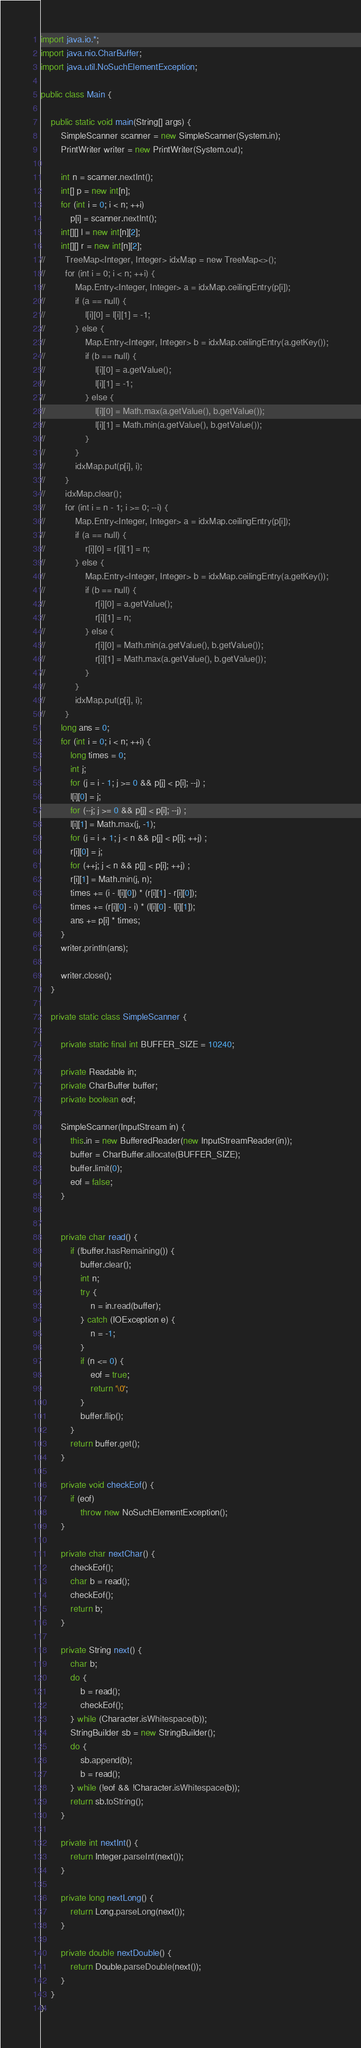<code> <loc_0><loc_0><loc_500><loc_500><_Java_>import java.io.*;
import java.nio.CharBuffer;
import java.util.NoSuchElementException;

public class Main {

    public static void main(String[] args) {
        SimpleScanner scanner = new SimpleScanner(System.in);
        PrintWriter writer = new PrintWriter(System.out);

        int n = scanner.nextInt();
        int[] p = new int[n];
        for (int i = 0; i < n; ++i)
            p[i] = scanner.nextInt();
        int[][] l = new int[n][2];
        int[][] r = new int[n][2];
//        TreeMap<Integer, Integer> idxMap = new TreeMap<>();
//        for (int i = 0; i < n; ++i) {
//            Map.Entry<Integer, Integer> a = idxMap.ceilingEntry(p[i]);
//            if (a == null) {
//                l[i][0] = l[i][1] = -1;
//            } else {
//                Map.Entry<Integer, Integer> b = idxMap.ceilingEntry(a.getKey());
//                if (b == null) {
//                    l[i][0] = a.getValue();
//                    l[i][1] = -1;
//                } else {
//                    l[i][0] = Math.max(a.getValue(), b.getValue());
//                    l[i][1] = Math.min(a.getValue(), b.getValue());
//                }
//            }
//            idxMap.put(p[i], i);
//        }
//        idxMap.clear();
//        for (int i = n - 1; i >= 0; --i) {
//            Map.Entry<Integer, Integer> a = idxMap.ceilingEntry(p[i]);
//            if (a == null) {
//                r[i][0] = r[i][1] = n;
//            } else {
//                Map.Entry<Integer, Integer> b = idxMap.ceilingEntry(a.getKey());
//                if (b == null) {
//                    r[i][0] = a.getValue();
//                    r[i][1] = n;
//                } else {
//                    r[i][0] = Math.min(a.getValue(), b.getValue());
//                    r[i][1] = Math.max(a.getValue(), b.getValue());
//                }
//            }
//            idxMap.put(p[i], i);
//        }
        long ans = 0;
        for (int i = 0; i < n; ++i) {
            long times = 0;
            int j;
            for (j = i - 1; j >= 0 && p[j] < p[i]; --j) ;
            l[i][0] = j;
            for (--j; j >= 0 && p[j] < p[i]; --j) ;
            l[i][1] = Math.max(j, -1);
            for (j = i + 1; j < n && p[j] < p[i]; ++j) ;
            r[i][0] = j;
            for (++j; j < n && p[j] < p[i]; ++j) ;
            r[i][1] = Math.min(j, n);
            times += (i - l[i][0]) * (r[i][1] - r[i][0]);
            times += (r[i][0] - i) * (l[i][0] - l[i][1]);
            ans += p[i] * times;
        }
        writer.println(ans);

        writer.close();
    }

    private static class SimpleScanner {

        private static final int BUFFER_SIZE = 10240;

        private Readable in;
        private CharBuffer buffer;
        private boolean eof;

        SimpleScanner(InputStream in) {
            this.in = new BufferedReader(new InputStreamReader(in));
            buffer = CharBuffer.allocate(BUFFER_SIZE);
            buffer.limit(0);
            eof = false;
        }


        private char read() {
            if (!buffer.hasRemaining()) {
                buffer.clear();
                int n;
                try {
                    n = in.read(buffer);
                } catch (IOException e) {
                    n = -1;
                }
                if (n <= 0) {
                    eof = true;
                    return '\0';
                }
                buffer.flip();
            }
            return buffer.get();
        }

        private void checkEof() {
            if (eof)
                throw new NoSuchElementException();
        }

        private char nextChar() {
            checkEof();
            char b = read();
            checkEof();
            return b;
        }

        private String next() {
            char b;
            do {
                b = read();
                checkEof();
            } while (Character.isWhitespace(b));
            StringBuilder sb = new StringBuilder();
            do {
                sb.append(b);
                b = read();
            } while (!eof && !Character.isWhitespace(b));
            return sb.toString();
        }

        private int nextInt() {
            return Integer.parseInt(next());
        }

        private long nextLong() {
            return Long.parseLong(next());
        }

        private double nextDouble() {
            return Double.parseDouble(next());
        }
    }
}</code> 